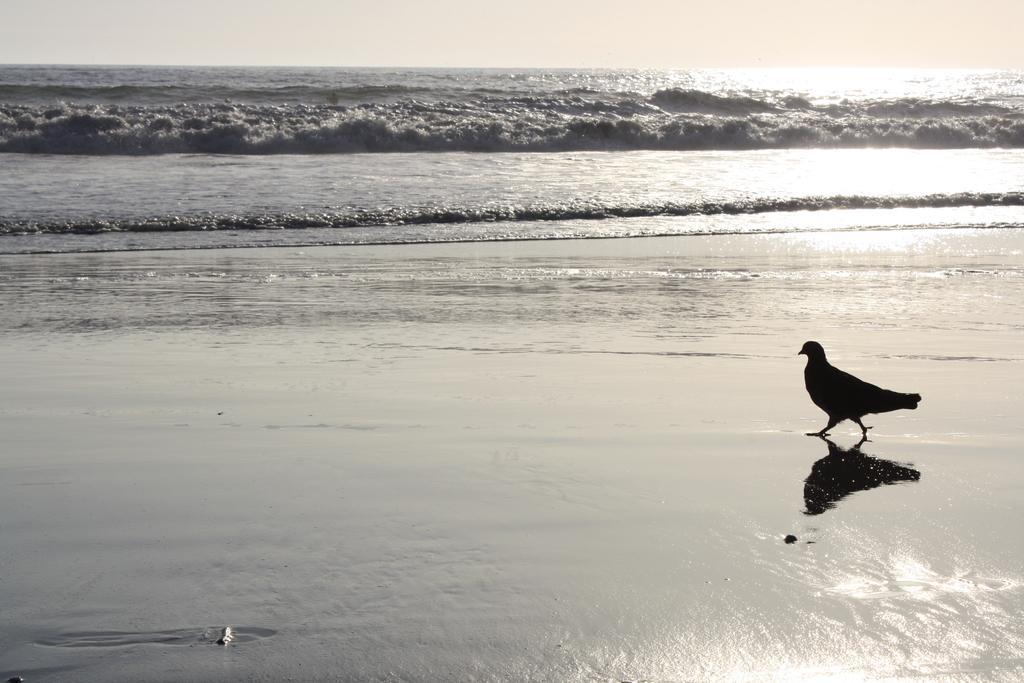Describe this image in one or two sentences. In this picture we can see a bird and in the background we can see water. 